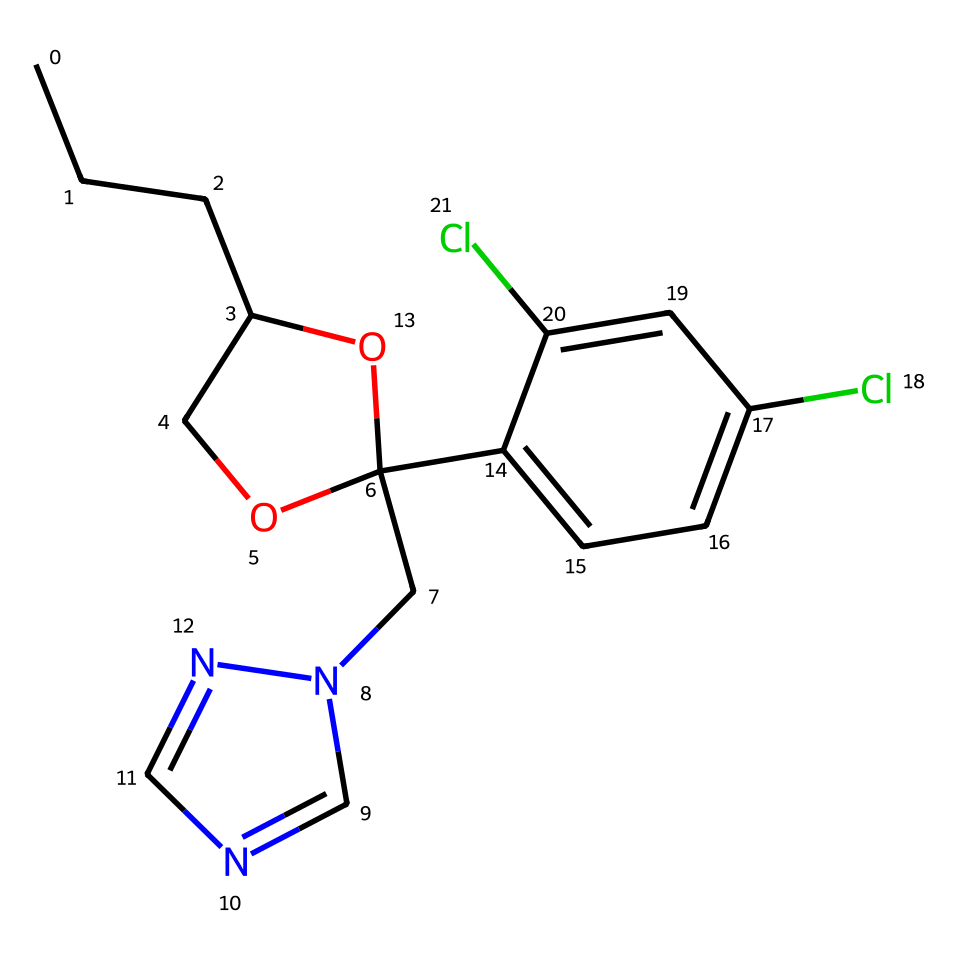What is the chemical name of the compound represented? The SMILES notation provides enough detail to deduce the complete IUPAC name of the chemical, which is propiconazole.
Answer: propiconazole How many chlorine atoms are present in the structure? By analyzing the SMILES representation, there are two occurrences of "Cl," indicating the presence of two chlorine atoms in the chemical structure.
Answer: 2 What functional group is indicated by the presence of “O” in the structure? The presence of "O" typically represents an alcohol or ether functional group in organic compounds. In this case, the oxygen in the structure contributes to the ether functionality.
Answer: ether How many rings are present in the chemical structure? In the provided SMILES, the sections marked with numbers (1 and 2) indicate closed ring structures, indicating there are two rings in total.
Answer: 2 What type of compound is propiconazole classified as? Given that propiconazole is used specifically as a fungicide, it is classified under this category, denoting its function in inhibiting fungal growth.
Answer: fungicide What is the primary element present in the longest carbon chain of the structure? The longest chain in the SMILES representation consists mainly of carbon atoms (denoted by "C"), establishing that carbon is the primary element in that segment.
Answer: carbon 